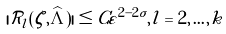<formula> <loc_0><loc_0><loc_500><loc_500>| \mathcal { R } _ { l } ( \zeta , \widehat { \Lambda } ) | \leq C \varepsilon ^ { 2 - 2 \sigma } , l = 2 , \dots , k</formula> 